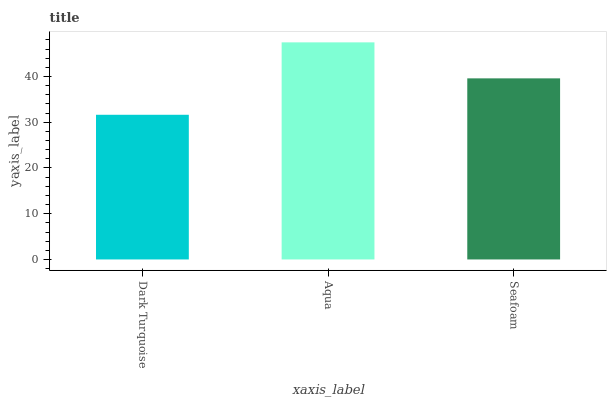Is Dark Turquoise the minimum?
Answer yes or no. Yes. Is Aqua the maximum?
Answer yes or no. Yes. Is Seafoam the minimum?
Answer yes or no. No. Is Seafoam the maximum?
Answer yes or no. No. Is Aqua greater than Seafoam?
Answer yes or no. Yes. Is Seafoam less than Aqua?
Answer yes or no. Yes. Is Seafoam greater than Aqua?
Answer yes or no. No. Is Aqua less than Seafoam?
Answer yes or no. No. Is Seafoam the high median?
Answer yes or no. Yes. Is Seafoam the low median?
Answer yes or no. Yes. Is Dark Turquoise the high median?
Answer yes or no. No. Is Dark Turquoise the low median?
Answer yes or no. No. 